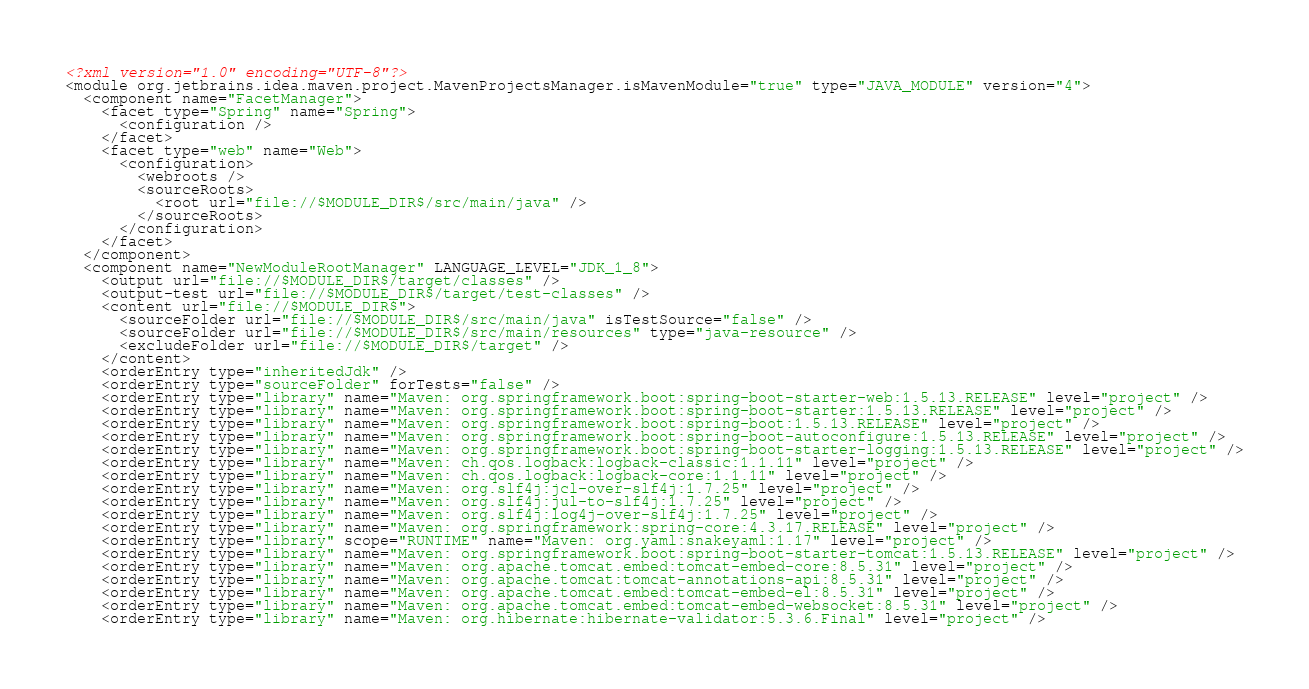Convert code to text. <code><loc_0><loc_0><loc_500><loc_500><_XML_><?xml version="1.0" encoding="UTF-8"?>
<module org.jetbrains.idea.maven.project.MavenProjectsManager.isMavenModule="true" type="JAVA_MODULE" version="4">
  <component name="FacetManager">
    <facet type="Spring" name="Spring">
      <configuration />
    </facet>
    <facet type="web" name="Web">
      <configuration>
        <webroots />
        <sourceRoots>
          <root url="file://$MODULE_DIR$/src/main/java" />
        </sourceRoots>
      </configuration>
    </facet>
  </component>
  <component name="NewModuleRootManager" LANGUAGE_LEVEL="JDK_1_8">
    <output url="file://$MODULE_DIR$/target/classes" />
    <output-test url="file://$MODULE_DIR$/target/test-classes" />
    <content url="file://$MODULE_DIR$">
      <sourceFolder url="file://$MODULE_DIR$/src/main/java" isTestSource="false" />
      <sourceFolder url="file://$MODULE_DIR$/src/main/resources" type="java-resource" />
      <excludeFolder url="file://$MODULE_DIR$/target" />
    </content>
    <orderEntry type="inheritedJdk" />
    <orderEntry type="sourceFolder" forTests="false" />
    <orderEntry type="library" name="Maven: org.springframework.boot:spring-boot-starter-web:1.5.13.RELEASE" level="project" />
    <orderEntry type="library" name="Maven: org.springframework.boot:spring-boot-starter:1.5.13.RELEASE" level="project" />
    <orderEntry type="library" name="Maven: org.springframework.boot:spring-boot:1.5.13.RELEASE" level="project" />
    <orderEntry type="library" name="Maven: org.springframework.boot:spring-boot-autoconfigure:1.5.13.RELEASE" level="project" />
    <orderEntry type="library" name="Maven: org.springframework.boot:spring-boot-starter-logging:1.5.13.RELEASE" level="project" />
    <orderEntry type="library" name="Maven: ch.qos.logback:logback-classic:1.1.11" level="project" />
    <orderEntry type="library" name="Maven: ch.qos.logback:logback-core:1.1.11" level="project" />
    <orderEntry type="library" name="Maven: org.slf4j:jcl-over-slf4j:1.7.25" level="project" />
    <orderEntry type="library" name="Maven: org.slf4j:jul-to-slf4j:1.7.25" level="project" />
    <orderEntry type="library" name="Maven: org.slf4j:log4j-over-slf4j:1.7.25" level="project" />
    <orderEntry type="library" name="Maven: org.springframework:spring-core:4.3.17.RELEASE" level="project" />
    <orderEntry type="library" scope="RUNTIME" name="Maven: org.yaml:snakeyaml:1.17" level="project" />
    <orderEntry type="library" name="Maven: org.springframework.boot:spring-boot-starter-tomcat:1.5.13.RELEASE" level="project" />
    <orderEntry type="library" name="Maven: org.apache.tomcat.embed:tomcat-embed-core:8.5.31" level="project" />
    <orderEntry type="library" name="Maven: org.apache.tomcat:tomcat-annotations-api:8.5.31" level="project" />
    <orderEntry type="library" name="Maven: org.apache.tomcat.embed:tomcat-embed-el:8.5.31" level="project" />
    <orderEntry type="library" name="Maven: org.apache.tomcat.embed:tomcat-embed-websocket:8.5.31" level="project" />
    <orderEntry type="library" name="Maven: org.hibernate:hibernate-validator:5.3.6.Final" level="project" /></code> 